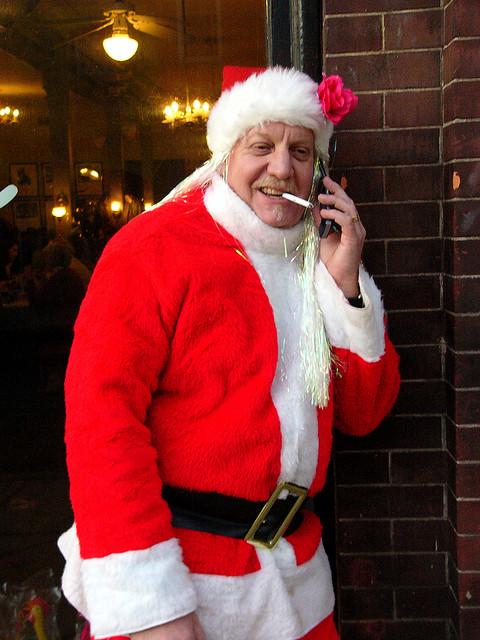What color is the suit?
Be succinct. Red. Is this a real Santa Claus?
Short answer required. No. What is in his mouth?
Keep it brief. Cigarette. 